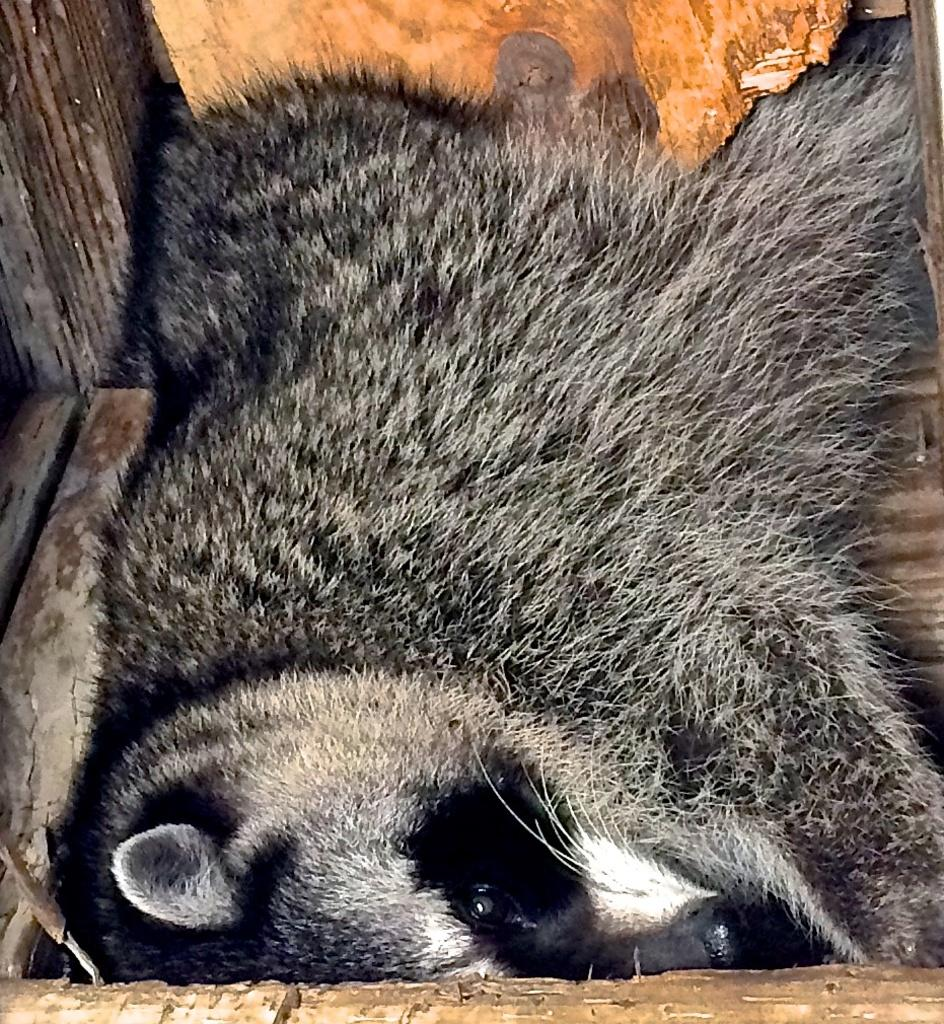What type of creature is in the image? There is an animal in the image. What color is the animal? The animal is black in color. Where is the animal located in the image? The animal is laying in a wooden box. What type of sock is the animal wearing in the image? There is no sock present in the image, and the animal is not wearing any clothing. 